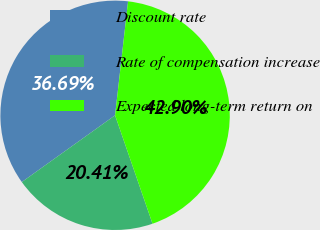<chart> <loc_0><loc_0><loc_500><loc_500><pie_chart><fcel>Discount rate<fcel>Rate of compensation increase<fcel>Expected long-term return on<nl><fcel>36.69%<fcel>20.41%<fcel>42.9%<nl></chart> 